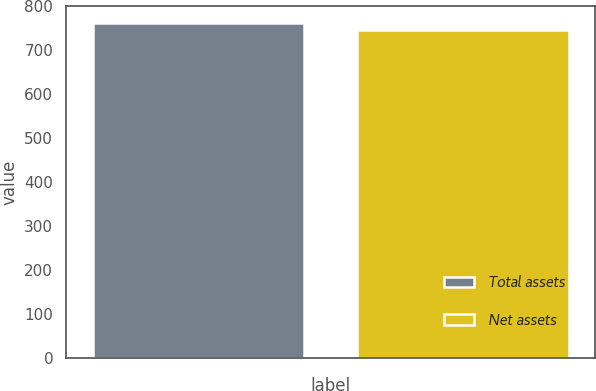Convert chart. <chart><loc_0><loc_0><loc_500><loc_500><bar_chart><fcel>Total assets<fcel>Net assets<nl><fcel>763<fcel>747<nl></chart> 